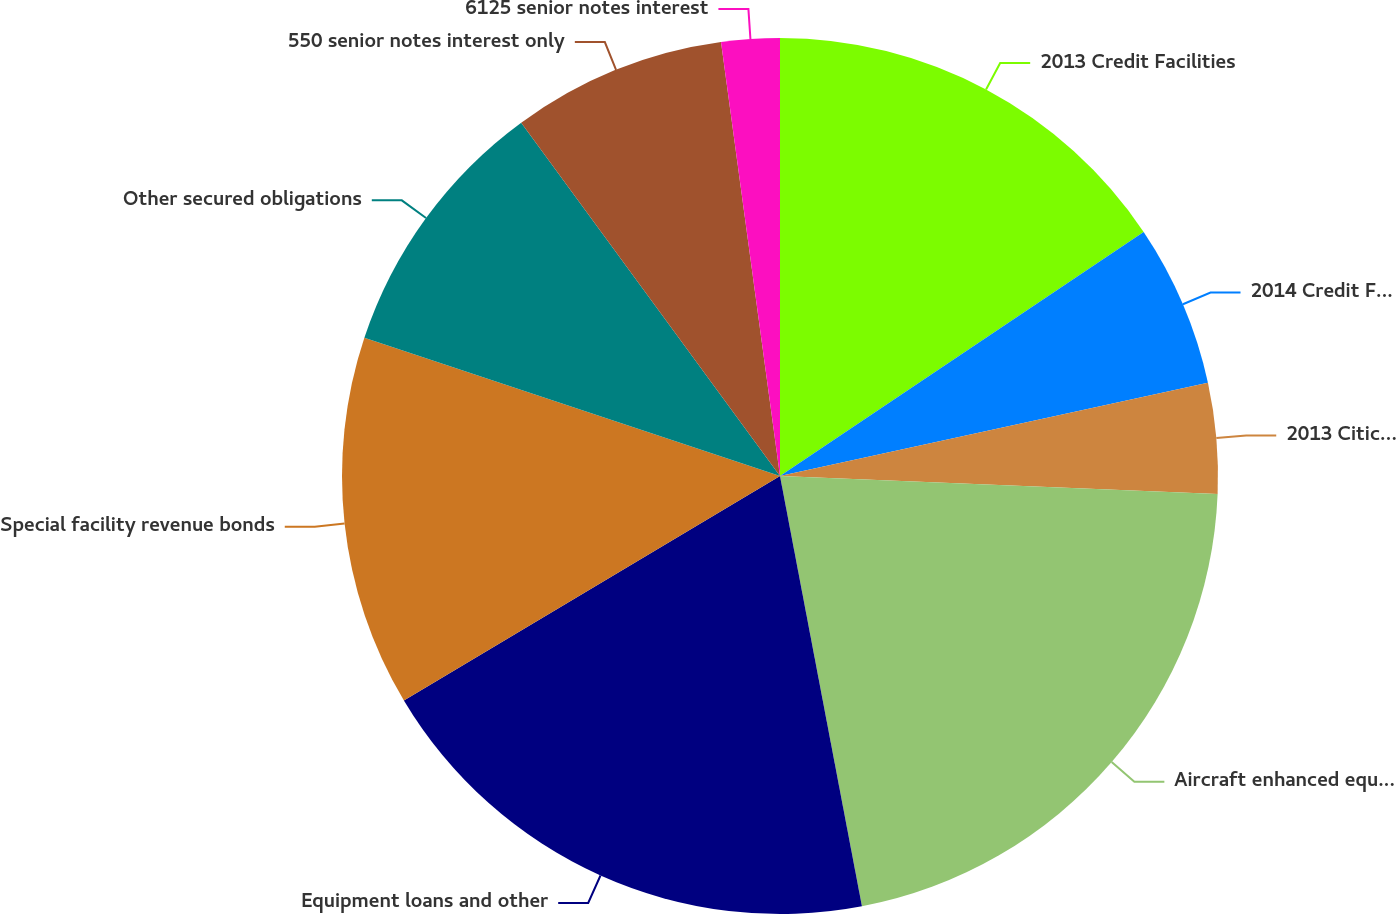Convert chart. <chart><loc_0><loc_0><loc_500><loc_500><pie_chart><fcel>2013 Credit Facilities<fcel>2014 Credit Facilities<fcel>2013 Citicorp Credit Facility<fcel>Aircraft enhanced equipment<fcel>Equipment loans and other<fcel>Special facility revenue bonds<fcel>Other secured obligations<fcel>550 senior notes interest only<fcel>6125 senior notes interest<nl><fcel>15.59%<fcel>5.99%<fcel>4.07%<fcel>21.35%<fcel>19.43%<fcel>13.67%<fcel>9.83%<fcel>7.91%<fcel>2.15%<nl></chart> 